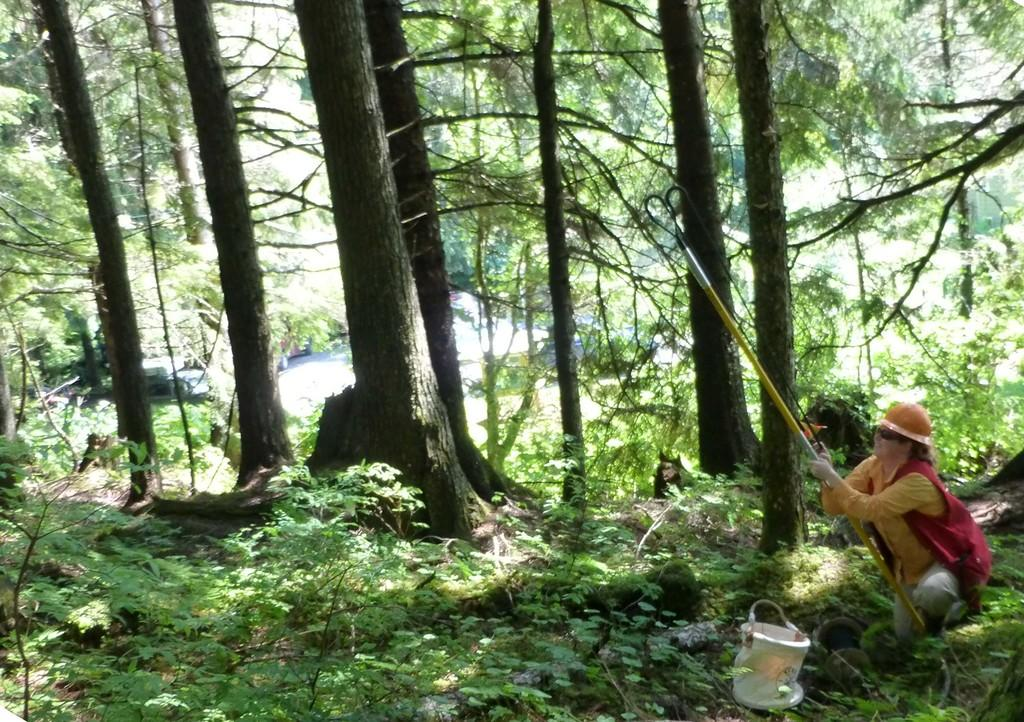What type of vegetation is present in the image? There are many trees and plants in the image. Can you describe the woman's position in the image? The woman is on the right side of the image. What is the woman holding in the image? The woman is holding a stick. What object is beside the woman in the image? There is a basket beside the woman. What does the desk smell like in the image? There is no desk present in the image, so it is not possible to determine what it might smell like. How does the woman cry in the image? The woman is not crying in the image; she is holding a stick and standing beside a basket. 